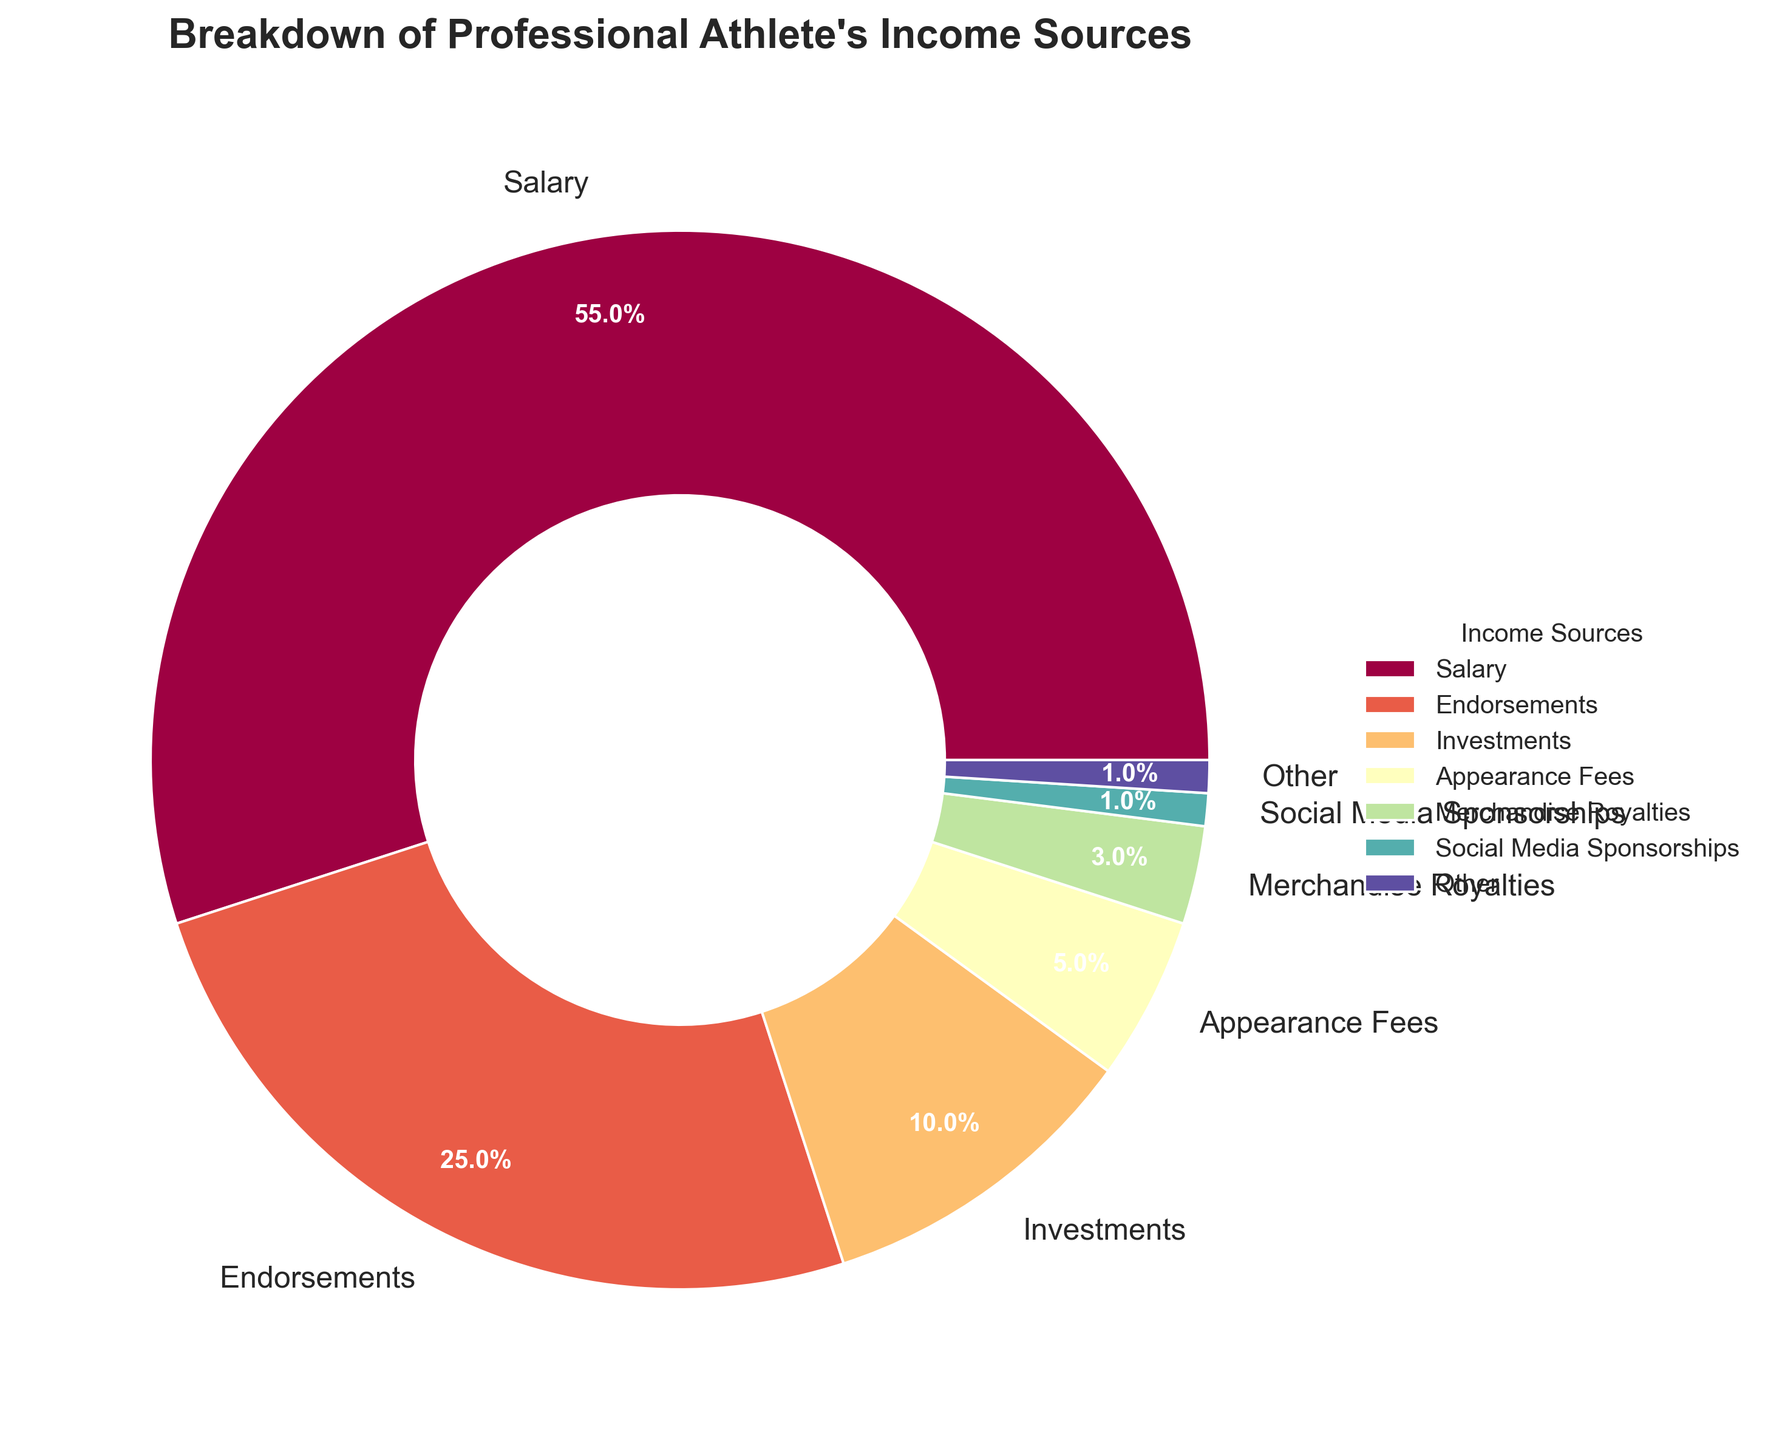What is the largest income source for professional athletes? The largest segment in the pie chart is labeled "Salary," with a percentage of 55%.
Answer: Salary What percentage comes from Endorsements compared to Salary? The percentage for Endorsements is 25%, while for Salary it is 55%. To find the ratio of Endorsements to Salary, divide 25 by 55, which is approximately 0.45 or 45%.
Answer: 45% What are the combined percentages for Appearance Fees, Merchandise Royalties, and Book Deals? Appearance Fees account for 5%, Merchandise Royalties for 3%, and Book Deals for 0.5%. Summing these values gives 5 + 3 + 0.5 = 8.5%.
Answer: 8.5% Which income source constitutes the smallest percentage? The smallest segment in the pie chart is labeled "Coaching Clinics" and "Restaurant Ownership," each with a percentage of 0.1%.
Answer: Coaching Clinics, Restaurant Ownership What is the combined percentage of income sources labeled as 'Other'? The filtered sources considered as 'Other' are Book Deals (0.5%), Speaking Engagements (0.3%), Coaching Clinics (0.1%), and Restaurant Ownership (0.1%). Summing these values gives 0.5 + 0.3 + 0.1 + 0.1 = 1%.
Answer: 1% 